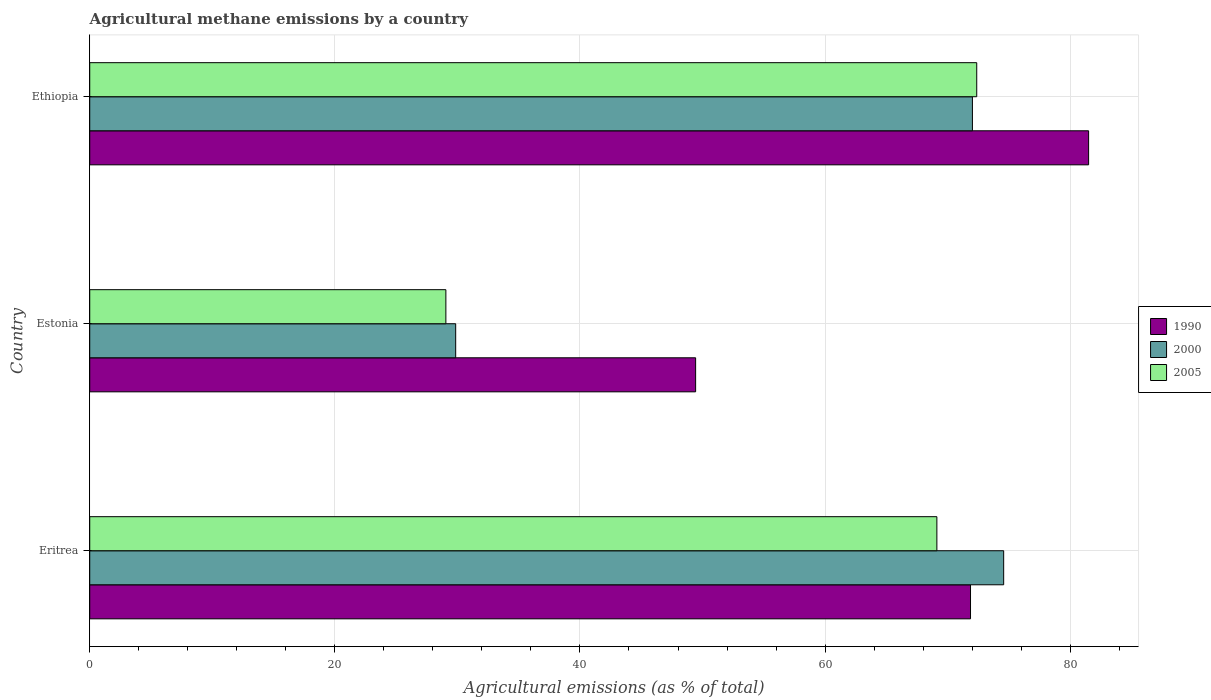How many different coloured bars are there?
Your answer should be compact. 3. How many groups of bars are there?
Ensure brevity in your answer.  3. Are the number of bars per tick equal to the number of legend labels?
Keep it short and to the point. Yes. Are the number of bars on each tick of the Y-axis equal?
Make the answer very short. Yes. How many bars are there on the 2nd tick from the bottom?
Your response must be concise. 3. What is the label of the 2nd group of bars from the top?
Provide a short and direct response. Estonia. In how many cases, is the number of bars for a given country not equal to the number of legend labels?
Your answer should be compact. 0. What is the amount of agricultural methane emitted in 2000 in Ethiopia?
Keep it short and to the point. 72.02. Across all countries, what is the maximum amount of agricultural methane emitted in 2005?
Give a very brief answer. 72.38. Across all countries, what is the minimum amount of agricultural methane emitted in 1990?
Offer a terse response. 49.44. In which country was the amount of agricultural methane emitted in 2005 maximum?
Offer a terse response. Ethiopia. In which country was the amount of agricultural methane emitted in 2000 minimum?
Keep it short and to the point. Estonia. What is the total amount of agricultural methane emitted in 2005 in the graph?
Make the answer very short. 170.56. What is the difference between the amount of agricultural methane emitted in 1990 in Eritrea and that in Ethiopia?
Ensure brevity in your answer.  -9.64. What is the difference between the amount of agricultural methane emitted in 2005 in Eritrea and the amount of agricultural methane emitted in 1990 in Ethiopia?
Your response must be concise. -12.38. What is the average amount of agricultural methane emitted in 1990 per country?
Your response must be concise. 67.6. What is the difference between the amount of agricultural methane emitted in 2005 and amount of agricultural methane emitted in 2000 in Estonia?
Your answer should be very brief. -0.8. What is the ratio of the amount of agricultural methane emitted in 2005 in Estonia to that in Ethiopia?
Provide a succinct answer. 0.4. Is the amount of agricultural methane emitted in 2005 in Eritrea less than that in Estonia?
Give a very brief answer. No. What is the difference between the highest and the second highest amount of agricultural methane emitted in 1990?
Provide a succinct answer. 9.64. What is the difference between the highest and the lowest amount of agricultural methane emitted in 2005?
Make the answer very short. 43.32. In how many countries, is the amount of agricultural methane emitted in 2005 greater than the average amount of agricultural methane emitted in 2005 taken over all countries?
Offer a very short reply. 2. What does the 3rd bar from the bottom in Estonia represents?
Offer a very short reply. 2005. How many bars are there?
Make the answer very short. 9. Are all the bars in the graph horizontal?
Ensure brevity in your answer.  Yes. What is the difference between two consecutive major ticks on the X-axis?
Your answer should be compact. 20. Does the graph contain any zero values?
Your answer should be compact. No. Where does the legend appear in the graph?
Offer a terse response. Center right. What is the title of the graph?
Your response must be concise. Agricultural methane emissions by a country. What is the label or title of the X-axis?
Give a very brief answer. Agricultural emissions (as % of total). What is the label or title of the Y-axis?
Your response must be concise. Country. What is the Agricultural emissions (as % of total) of 1990 in Eritrea?
Make the answer very short. 71.87. What is the Agricultural emissions (as % of total) in 2000 in Eritrea?
Give a very brief answer. 74.57. What is the Agricultural emissions (as % of total) of 2005 in Eritrea?
Offer a very short reply. 69.12. What is the Agricultural emissions (as % of total) of 1990 in Estonia?
Provide a succinct answer. 49.44. What is the Agricultural emissions (as % of total) in 2000 in Estonia?
Ensure brevity in your answer.  29.86. What is the Agricultural emissions (as % of total) in 2005 in Estonia?
Keep it short and to the point. 29.06. What is the Agricultural emissions (as % of total) of 1990 in Ethiopia?
Your answer should be compact. 81.5. What is the Agricultural emissions (as % of total) in 2000 in Ethiopia?
Your response must be concise. 72.02. What is the Agricultural emissions (as % of total) of 2005 in Ethiopia?
Give a very brief answer. 72.38. Across all countries, what is the maximum Agricultural emissions (as % of total) in 1990?
Provide a succinct answer. 81.5. Across all countries, what is the maximum Agricultural emissions (as % of total) of 2000?
Give a very brief answer. 74.57. Across all countries, what is the maximum Agricultural emissions (as % of total) of 2005?
Give a very brief answer. 72.38. Across all countries, what is the minimum Agricultural emissions (as % of total) of 1990?
Ensure brevity in your answer.  49.44. Across all countries, what is the minimum Agricultural emissions (as % of total) in 2000?
Your answer should be compact. 29.86. Across all countries, what is the minimum Agricultural emissions (as % of total) of 2005?
Your answer should be compact. 29.06. What is the total Agricultural emissions (as % of total) of 1990 in the graph?
Offer a very short reply. 202.81. What is the total Agricultural emissions (as % of total) in 2000 in the graph?
Your answer should be compact. 176.46. What is the total Agricultural emissions (as % of total) of 2005 in the graph?
Ensure brevity in your answer.  170.56. What is the difference between the Agricultural emissions (as % of total) of 1990 in Eritrea and that in Estonia?
Provide a succinct answer. 22.43. What is the difference between the Agricultural emissions (as % of total) in 2000 in Eritrea and that in Estonia?
Ensure brevity in your answer.  44.71. What is the difference between the Agricultural emissions (as % of total) of 2005 in Eritrea and that in Estonia?
Provide a short and direct response. 40.06. What is the difference between the Agricultural emissions (as % of total) of 1990 in Eritrea and that in Ethiopia?
Offer a very short reply. -9.64. What is the difference between the Agricultural emissions (as % of total) in 2000 in Eritrea and that in Ethiopia?
Give a very brief answer. 2.55. What is the difference between the Agricultural emissions (as % of total) in 2005 in Eritrea and that in Ethiopia?
Your response must be concise. -3.25. What is the difference between the Agricultural emissions (as % of total) in 1990 in Estonia and that in Ethiopia?
Provide a succinct answer. -32.07. What is the difference between the Agricultural emissions (as % of total) in 2000 in Estonia and that in Ethiopia?
Your answer should be compact. -42.16. What is the difference between the Agricultural emissions (as % of total) in 2005 in Estonia and that in Ethiopia?
Give a very brief answer. -43.32. What is the difference between the Agricultural emissions (as % of total) in 1990 in Eritrea and the Agricultural emissions (as % of total) in 2000 in Estonia?
Offer a very short reply. 42.01. What is the difference between the Agricultural emissions (as % of total) in 1990 in Eritrea and the Agricultural emissions (as % of total) in 2005 in Estonia?
Offer a terse response. 42.81. What is the difference between the Agricultural emissions (as % of total) in 2000 in Eritrea and the Agricultural emissions (as % of total) in 2005 in Estonia?
Offer a very short reply. 45.51. What is the difference between the Agricultural emissions (as % of total) of 1990 in Eritrea and the Agricultural emissions (as % of total) of 2000 in Ethiopia?
Your answer should be compact. -0.16. What is the difference between the Agricultural emissions (as % of total) of 1990 in Eritrea and the Agricultural emissions (as % of total) of 2005 in Ethiopia?
Give a very brief answer. -0.51. What is the difference between the Agricultural emissions (as % of total) of 2000 in Eritrea and the Agricultural emissions (as % of total) of 2005 in Ethiopia?
Ensure brevity in your answer.  2.2. What is the difference between the Agricultural emissions (as % of total) of 1990 in Estonia and the Agricultural emissions (as % of total) of 2000 in Ethiopia?
Keep it short and to the point. -22.59. What is the difference between the Agricultural emissions (as % of total) of 1990 in Estonia and the Agricultural emissions (as % of total) of 2005 in Ethiopia?
Your answer should be compact. -22.94. What is the difference between the Agricultural emissions (as % of total) of 2000 in Estonia and the Agricultural emissions (as % of total) of 2005 in Ethiopia?
Your answer should be very brief. -42.52. What is the average Agricultural emissions (as % of total) in 1990 per country?
Your response must be concise. 67.6. What is the average Agricultural emissions (as % of total) in 2000 per country?
Provide a short and direct response. 58.82. What is the average Agricultural emissions (as % of total) of 2005 per country?
Your response must be concise. 56.85. What is the difference between the Agricultural emissions (as % of total) of 1990 and Agricultural emissions (as % of total) of 2000 in Eritrea?
Give a very brief answer. -2.71. What is the difference between the Agricultural emissions (as % of total) in 1990 and Agricultural emissions (as % of total) in 2005 in Eritrea?
Offer a very short reply. 2.75. What is the difference between the Agricultural emissions (as % of total) of 2000 and Agricultural emissions (as % of total) of 2005 in Eritrea?
Make the answer very short. 5.45. What is the difference between the Agricultural emissions (as % of total) in 1990 and Agricultural emissions (as % of total) in 2000 in Estonia?
Provide a short and direct response. 19.58. What is the difference between the Agricultural emissions (as % of total) of 1990 and Agricultural emissions (as % of total) of 2005 in Estonia?
Ensure brevity in your answer.  20.38. What is the difference between the Agricultural emissions (as % of total) in 2000 and Agricultural emissions (as % of total) in 2005 in Estonia?
Offer a terse response. 0.8. What is the difference between the Agricultural emissions (as % of total) in 1990 and Agricultural emissions (as % of total) in 2000 in Ethiopia?
Your answer should be very brief. 9.48. What is the difference between the Agricultural emissions (as % of total) of 1990 and Agricultural emissions (as % of total) of 2005 in Ethiopia?
Provide a short and direct response. 9.13. What is the difference between the Agricultural emissions (as % of total) in 2000 and Agricultural emissions (as % of total) in 2005 in Ethiopia?
Ensure brevity in your answer.  -0.35. What is the ratio of the Agricultural emissions (as % of total) of 1990 in Eritrea to that in Estonia?
Give a very brief answer. 1.45. What is the ratio of the Agricultural emissions (as % of total) of 2000 in Eritrea to that in Estonia?
Offer a very short reply. 2.5. What is the ratio of the Agricultural emissions (as % of total) in 2005 in Eritrea to that in Estonia?
Offer a very short reply. 2.38. What is the ratio of the Agricultural emissions (as % of total) in 1990 in Eritrea to that in Ethiopia?
Offer a very short reply. 0.88. What is the ratio of the Agricultural emissions (as % of total) of 2000 in Eritrea to that in Ethiopia?
Ensure brevity in your answer.  1.04. What is the ratio of the Agricultural emissions (as % of total) in 2005 in Eritrea to that in Ethiopia?
Your answer should be very brief. 0.96. What is the ratio of the Agricultural emissions (as % of total) of 1990 in Estonia to that in Ethiopia?
Give a very brief answer. 0.61. What is the ratio of the Agricultural emissions (as % of total) in 2000 in Estonia to that in Ethiopia?
Your response must be concise. 0.41. What is the ratio of the Agricultural emissions (as % of total) of 2005 in Estonia to that in Ethiopia?
Make the answer very short. 0.4. What is the difference between the highest and the second highest Agricultural emissions (as % of total) in 1990?
Keep it short and to the point. 9.64. What is the difference between the highest and the second highest Agricultural emissions (as % of total) of 2000?
Ensure brevity in your answer.  2.55. What is the difference between the highest and the second highest Agricultural emissions (as % of total) of 2005?
Ensure brevity in your answer.  3.25. What is the difference between the highest and the lowest Agricultural emissions (as % of total) of 1990?
Offer a terse response. 32.07. What is the difference between the highest and the lowest Agricultural emissions (as % of total) in 2000?
Your answer should be compact. 44.71. What is the difference between the highest and the lowest Agricultural emissions (as % of total) of 2005?
Your answer should be very brief. 43.32. 